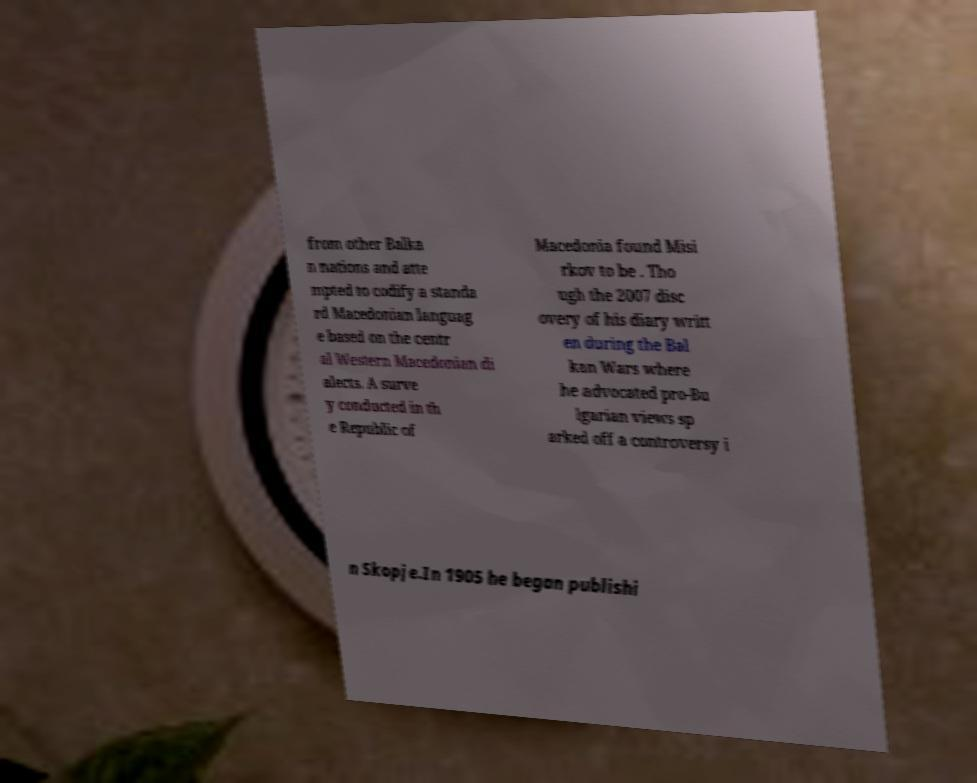Please read and relay the text visible in this image. What does it say? from other Balka n nations and atte mpted to codify a standa rd Macedonian languag e based on the centr al Western Macedonian di alects. A surve y conducted in th e Republic of Macedonia found Misi rkov to be . Tho ugh the 2007 disc overy of his diary writt en during the Bal kan Wars where he advocated pro-Bu lgarian views sp arked off a controversy i n Skopje.In 1905 he began publishi 